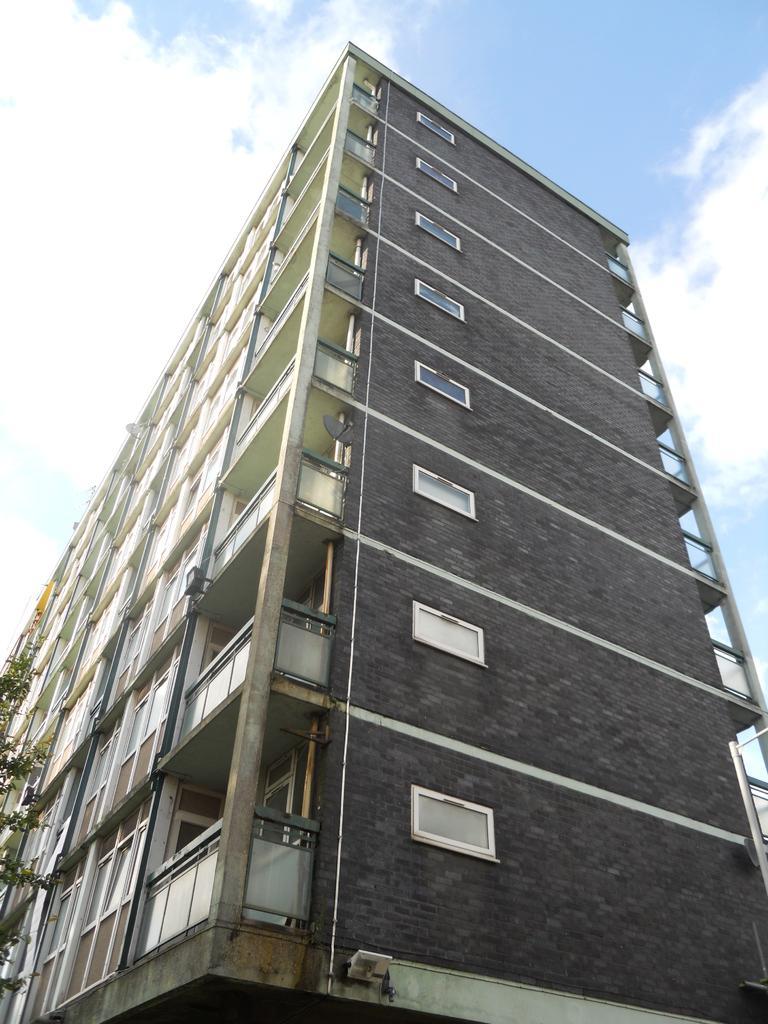Please provide a concise description of this image. In this picture I can see there is a building, it has few windows and balconies. There is a tree at the left side and the sky is clear. 